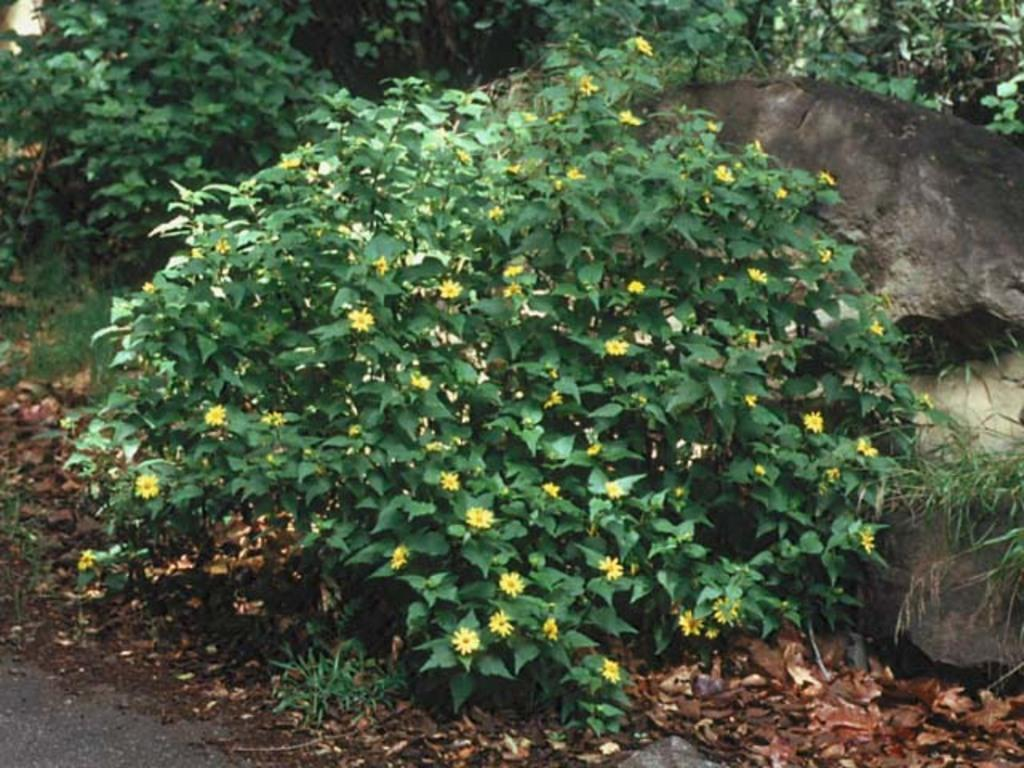What type of plants can be seen in the image? There are flowering plants in the image. What type of vegetation is present besides the flowering plants? There is grass in the image. Can you describe any other objects or features in the image? There is a rock on the right side of the image. What type of chain can be seen connecting the flowering plants in the image? There is no chain present in the image; the flowering plants are not connected by any visible chain. 